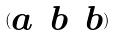Convert formula to latex. <formula><loc_0><loc_0><loc_500><loc_500>( \begin{matrix} a & b & b \end{matrix} )</formula> 